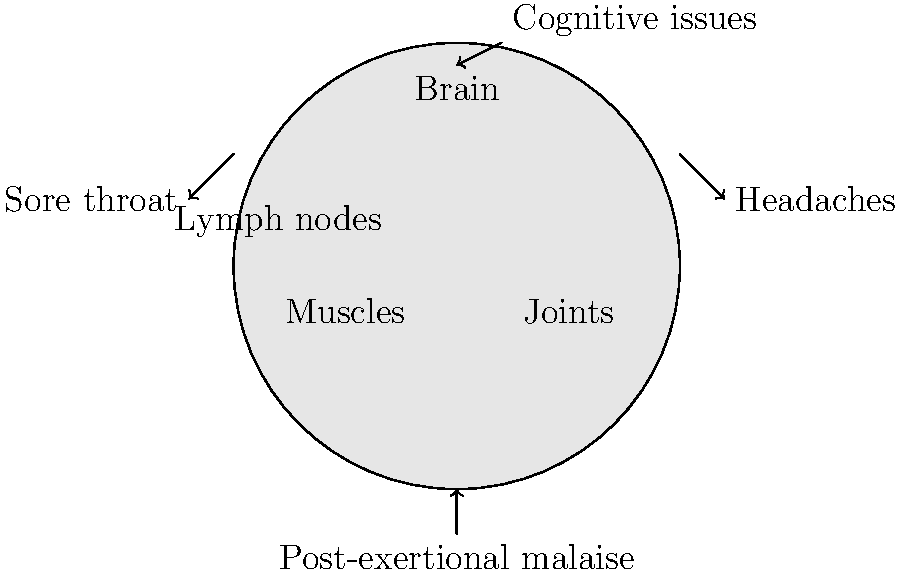Using the body diagram provided, identify the four key symptoms of chronic fatigue syndrome (CFS) indicated by the arrows. Which of these symptoms is considered the hallmark characteristic of CFS, distinguishing it from other fatigue-related conditions? To answer this question, let's analyze the body diagram and the symptoms indicated:

1. The arrow pointing to the brain is labeled "Cognitive issues," which is a common symptom in CFS patients, often referred to as "brain fog."

2. The arrow pointing to the throat area is labeled "Sore throat," which is another frequent symptom in CFS.

3. The arrow pointing to the head region is labeled "Headaches," which are often reported by CFS patients.

4. The arrow pointing to the lower body is labeled "Post-exertional malaise," which refers to the worsening of symptoms after physical or mental exertion.

Among these four symptoms, post-exertional malaise (PEM) is considered the hallmark characteristic of CFS. PEM is defined as the exacerbation of symptoms following physical or cognitive exertion, often with a delayed onset (typically 24-48 hours after the triggering activity). This symptom distinguishes CFS from other fatigue-related conditions because:

a) It is not present in all fatigue-related disorders.
b) The severity and duration of PEM in CFS are typically more pronounced than in other conditions.
c) PEM in CFS often has a delayed onset, which is not typical in other fatigue-related disorders.
d) The presence of PEM is a key diagnostic criterion for CFS according to most current diagnostic guidelines.

While cognitive issues, sore throat, and headaches are common in CFS, they can also be present in various other conditions. The unique presentation of PEM in CFS makes it the most distinguishing feature of the syndrome.
Answer: Post-exertional malaise (PEM) 